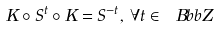<formula> <loc_0><loc_0><loc_500><loc_500>K \circ S ^ { t } \circ K = S ^ { - t } , \, \forall t \in { \ B b b Z }</formula> 